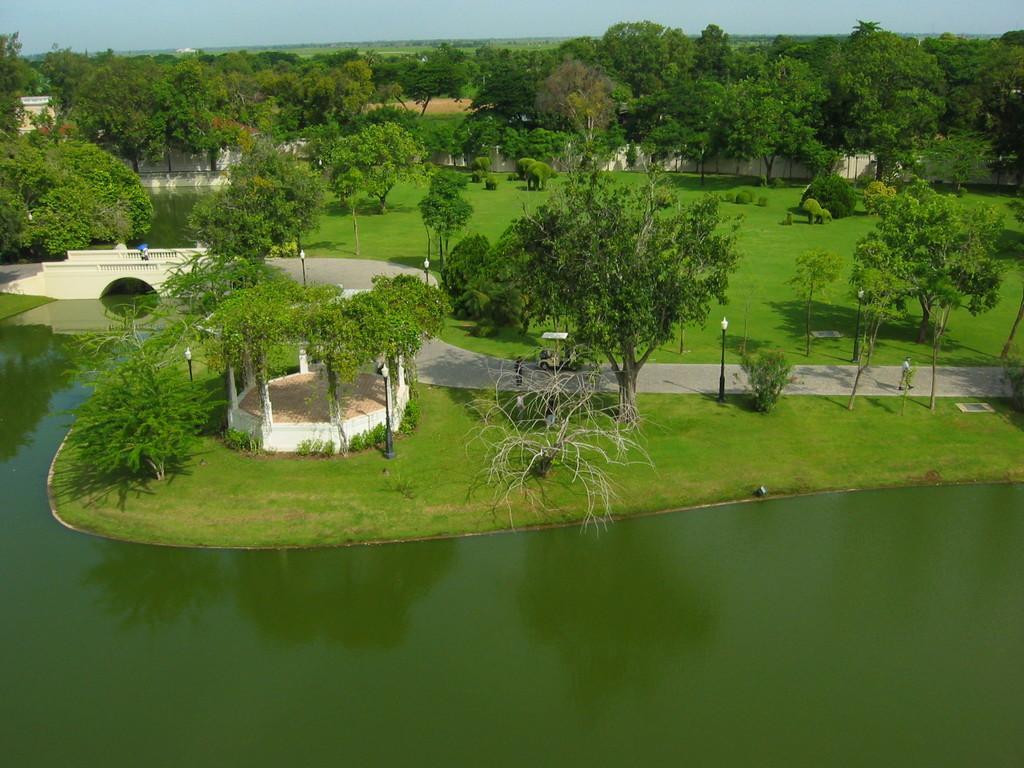Could you give a brief overview of what you see in this image? In this picture I can see trees buildings and I can see a wall and few plants and I can see few people are walking and few pole lights and looks like a vehicle and I can see water and grass on the ground and I can see a blue sky. 